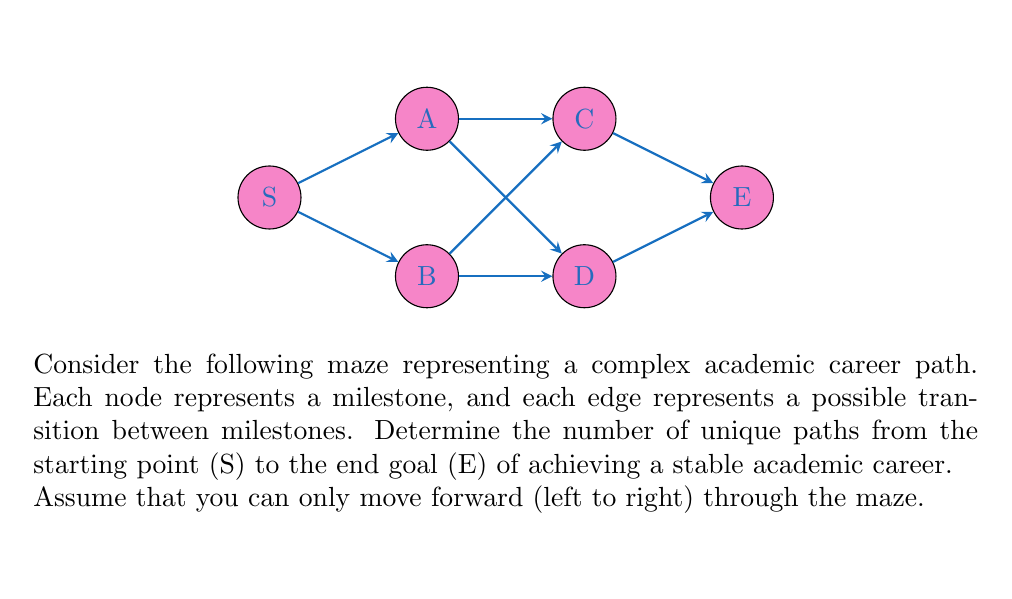What is the answer to this math problem? To solve this problem, we'll use the principle of dynamic programming and break it down step-by-step:

1) First, let's label the number of paths to reach each node:
   - S has 1 path (the starting point)
   - A and B will each have 1 path from S

2) For C, we can reach it from:
   - A (1 path)
   - B (1 path)
   So, C has 1 + 1 = 2 paths

3) Similarly for D, we can reach it from:
   - A (1 path)
   - B (1 path)
   So, D also has 1 + 1 = 2 paths

4) Finally, for E, we can reach it from:
   - C (2 paths)
   - D (2 paths)
   So, E has 2 + 2 = 4 paths

5) We can represent this mathematically:
   Let $P(X)$ be the number of paths to node X.
   
   $$P(S) = 1$$
   $$P(A) = P(B) = 1$$
   $$P(C) = P(A) + P(B) = 1 + 1 = 2$$
   $$P(D) = P(A) + P(B) = 1 + 1 = 2$$
   $$P(E) = P(C) + P(D) = 2 + 2 = 4$$

Therefore, there are 4 unique paths from S to E in this academic career maze.
Answer: 4 paths 